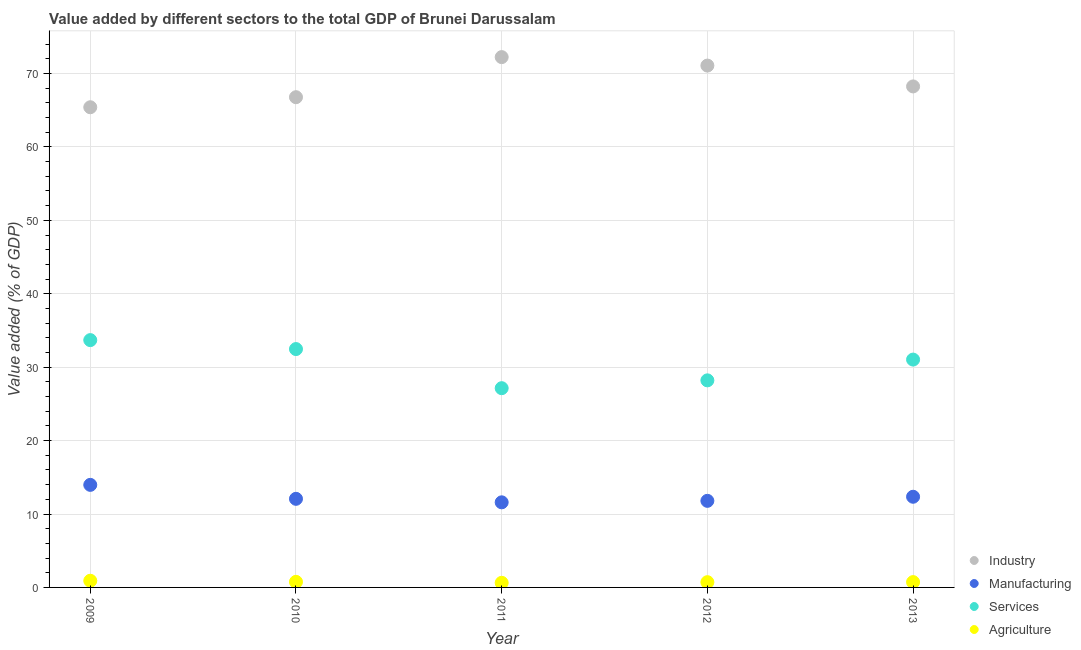What is the value added by manufacturing sector in 2010?
Make the answer very short. 12.07. Across all years, what is the maximum value added by industrial sector?
Give a very brief answer. 72.23. Across all years, what is the minimum value added by services sector?
Offer a terse response. 27.14. In which year was the value added by manufacturing sector minimum?
Ensure brevity in your answer.  2011. What is the total value added by manufacturing sector in the graph?
Give a very brief answer. 61.77. What is the difference between the value added by manufacturing sector in 2012 and that in 2013?
Your answer should be compact. -0.56. What is the difference between the value added by agricultural sector in 2011 and the value added by services sector in 2013?
Offer a very short reply. -30.41. What is the average value added by industrial sector per year?
Your response must be concise. 68.75. In the year 2011, what is the difference between the value added by manufacturing sector and value added by agricultural sector?
Make the answer very short. 10.96. In how many years, is the value added by services sector greater than 56 %?
Your answer should be compact. 0. What is the ratio of the value added by industrial sector in 2011 to that in 2013?
Your answer should be very brief. 1.06. What is the difference between the highest and the second highest value added by industrial sector?
Give a very brief answer. 1.15. What is the difference between the highest and the lowest value added by industrial sector?
Keep it short and to the point. 6.83. Is the sum of the value added by industrial sector in 2009 and 2012 greater than the maximum value added by services sector across all years?
Provide a short and direct response. Yes. Is it the case that in every year, the sum of the value added by manufacturing sector and value added by industrial sector is greater than the sum of value added by services sector and value added by agricultural sector?
Your response must be concise. Yes. Does the value added by industrial sector monotonically increase over the years?
Make the answer very short. No. Is the value added by manufacturing sector strictly less than the value added by agricultural sector over the years?
Your answer should be very brief. No. How many dotlines are there?
Your answer should be very brief. 4. How many years are there in the graph?
Offer a very short reply. 5. What is the difference between two consecutive major ticks on the Y-axis?
Provide a succinct answer. 10. Does the graph contain grids?
Your answer should be compact. Yes. Where does the legend appear in the graph?
Offer a very short reply. Bottom right. What is the title of the graph?
Offer a terse response. Value added by different sectors to the total GDP of Brunei Darussalam. Does "Secondary general" appear as one of the legend labels in the graph?
Give a very brief answer. No. What is the label or title of the Y-axis?
Offer a very short reply. Value added (% of GDP). What is the Value added (% of GDP) of Industry in 2009?
Your response must be concise. 65.41. What is the Value added (% of GDP) of Manufacturing in 2009?
Your answer should be compact. 13.97. What is the Value added (% of GDP) in Services in 2009?
Keep it short and to the point. 33.69. What is the Value added (% of GDP) in Agriculture in 2009?
Offer a very short reply. 0.91. What is the Value added (% of GDP) of Industry in 2010?
Keep it short and to the point. 66.77. What is the Value added (% of GDP) in Manufacturing in 2010?
Ensure brevity in your answer.  12.07. What is the Value added (% of GDP) of Services in 2010?
Ensure brevity in your answer.  32.47. What is the Value added (% of GDP) in Agriculture in 2010?
Make the answer very short. 0.76. What is the Value added (% of GDP) in Industry in 2011?
Your response must be concise. 72.23. What is the Value added (% of GDP) in Manufacturing in 2011?
Offer a very short reply. 11.59. What is the Value added (% of GDP) of Services in 2011?
Give a very brief answer. 27.14. What is the Value added (% of GDP) of Agriculture in 2011?
Make the answer very short. 0.63. What is the Value added (% of GDP) in Industry in 2012?
Your answer should be compact. 71.08. What is the Value added (% of GDP) in Manufacturing in 2012?
Ensure brevity in your answer.  11.79. What is the Value added (% of GDP) in Services in 2012?
Provide a succinct answer. 28.21. What is the Value added (% of GDP) in Agriculture in 2012?
Provide a short and direct response. 0.72. What is the Value added (% of GDP) in Industry in 2013?
Keep it short and to the point. 68.24. What is the Value added (% of GDP) of Manufacturing in 2013?
Your answer should be very brief. 12.35. What is the Value added (% of GDP) of Services in 2013?
Ensure brevity in your answer.  31.03. What is the Value added (% of GDP) in Agriculture in 2013?
Give a very brief answer. 0.73. Across all years, what is the maximum Value added (% of GDP) of Industry?
Keep it short and to the point. 72.23. Across all years, what is the maximum Value added (% of GDP) in Manufacturing?
Your response must be concise. 13.97. Across all years, what is the maximum Value added (% of GDP) in Services?
Make the answer very short. 33.69. Across all years, what is the maximum Value added (% of GDP) of Agriculture?
Provide a succinct answer. 0.91. Across all years, what is the minimum Value added (% of GDP) in Industry?
Your response must be concise. 65.41. Across all years, what is the minimum Value added (% of GDP) in Manufacturing?
Your answer should be compact. 11.59. Across all years, what is the minimum Value added (% of GDP) of Services?
Your answer should be compact. 27.14. Across all years, what is the minimum Value added (% of GDP) in Agriculture?
Ensure brevity in your answer.  0.63. What is the total Value added (% of GDP) of Industry in the graph?
Offer a very short reply. 343.73. What is the total Value added (% of GDP) of Manufacturing in the graph?
Keep it short and to the point. 61.77. What is the total Value added (% of GDP) in Services in the graph?
Keep it short and to the point. 152.53. What is the total Value added (% of GDP) in Agriculture in the graph?
Make the answer very short. 3.74. What is the difference between the Value added (% of GDP) of Industry in 2009 and that in 2010?
Give a very brief answer. -1.37. What is the difference between the Value added (% of GDP) of Manufacturing in 2009 and that in 2010?
Give a very brief answer. 1.9. What is the difference between the Value added (% of GDP) of Services in 2009 and that in 2010?
Make the answer very short. 1.22. What is the difference between the Value added (% of GDP) of Agriculture in 2009 and that in 2010?
Make the answer very short. 0.15. What is the difference between the Value added (% of GDP) of Industry in 2009 and that in 2011?
Keep it short and to the point. -6.83. What is the difference between the Value added (% of GDP) in Manufacturing in 2009 and that in 2011?
Provide a succinct answer. 2.38. What is the difference between the Value added (% of GDP) in Services in 2009 and that in 2011?
Make the answer very short. 6.55. What is the difference between the Value added (% of GDP) of Agriculture in 2009 and that in 2011?
Your answer should be very brief. 0.28. What is the difference between the Value added (% of GDP) in Industry in 2009 and that in 2012?
Offer a terse response. -5.67. What is the difference between the Value added (% of GDP) in Manufacturing in 2009 and that in 2012?
Your response must be concise. 2.18. What is the difference between the Value added (% of GDP) in Services in 2009 and that in 2012?
Your response must be concise. 5.48. What is the difference between the Value added (% of GDP) of Agriculture in 2009 and that in 2012?
Provide a short and direct response. 0.19. What is the difference between the Value added (% of GDP) of Industry in 2009 and that in 2013?
Provide a succinct answer. -2.84. What is the difference between the Value added (% of GDP) in Manufacturing in 2009 and that in 2013?
Ensure brevity in your answer.  1.62. What is the difference between the Value added (% of GDP) of Services in 2009 and that in 2013?
Your answer should be very brief. 2.65. What is the difference between the Value added (% of GDP) of Agriculture in 2009 and that in 2013?
Provide a short and direct response. 0.18. What is the difference between the Value added (% of GDP) of Industry in 2010 and that in 2011?
Provide a succinct answer. -5.46. What is the difference between the Value added (% of GDP) in Manufacturing in 2010 and that in 2011?
Provide a succinct answer. 0.48. What is the difference between the Value added (% of GDP) in Services in 2010 and that in 2011?
Provide a succinct answer. 5.33. What is the difference between the Value added (% of GDP) in Agriculture in 2010 and that in 2011?
Provide a short and direct response. 0.13. What is the difference between the Value added (% of GDP) of Industry in 2010 and that in 2012?
Ensure brevity in your answer.  -4.31. What is the difference between the Value added (% of GDP) in Manufacturing in 2010 and that in 2012?
Your response must be concise. 0.27. What is the difference between the Value added (% of GDP) in Services in 2010 and that in 2012?
Your answer should be very brief. 4.26. What is the difference between the Value added (% of GDP) of Agriculture in 2010 and that in 2012?
Offer a terse response. 0.04. What is the difference between the Value added (% of GDP) in Industry in 2010 and that in 2013?
Your answer should be compact. -1.47. What is the difference between the Value added (% of GDP) in Manufacturing in 2010 and that in 2013?
Provide a succinct answer. -0.28. What is the difference between the Value added (% of GDP) of Services in 2010 and that in 2013?
Offer a very short reply. 1.43. What is the difference between the Value added (% of GDP) in Agriculture in 2010 and that in 2013?
Your answer should be compact. 0.03. What is the difference between the Value added (% of GDP) in Industry in 2011 and that in 2012?
Offer a terse response. 1.15. What is the difference between the Value added (% of GDP) of Manufacturing in 2011 and that in 2012?
Make the answer very short. -0.2. What is the difference between the Value added (% of GDP) in Services in 2011 and that in 2012?
Ensure brevity in your answer.  -1.07. What is the difference between the Value added (% of GDP) of Agriculture in 2011 and that in 2012?
Keep it short and to the point. -0.09. What is the difference between the Value added (% of GDP) in Industry in 2011 and that in 2013?
Your response must be concise. 3.99. What is the difference between the Value added (% of GDP) of Manufacturing in 2011 and that in 2013?
Give a very brief answer. -0.76. What is the difference between the Value added (% of GDP) in Services in 2011 and that in 2013?
Your answer should be compact. -3.9. What is the difference between the Value added (% of GDP) of Agriculture in 2011 and that in 2013?
Your answer should be very brief. -0.1. What is the difference between the Value added (% of GDP) in Industry in 2012 and that in 2013?
Offer a very short reply. 2.84. What is the difference between the Value added (% of GDP) of Manufacturing in 2012 and that in 2013?
Your answer should be compact. -0.56. What is the difference between the Value added (% of GDP) of Services in 2012 and that in 2013?
Offer a terse response. -2.83. What is the difference between the Value added (% of GDP) of Agriculture in 2012 and that in 2013?
Offer a very short reply. -0.01. What is the difference between the Value added (% of GDP) of Industry in 2009 and the Value added (% of GDP) of Manufacturing in 2010?
Your answer should be compact. 53.34. What is the difference between the Value added (% of GDP) in Industry in 2009 and the Value added (% of GDP) in Services in 2010?
Your answer should be compact. 32.94. What is the difference between the Value added (% of GDP) in Industry in 2009 and the Value added (% of GDP) in Agriculture in 2010?
Keep it short and to the point. 64.65. What is the difference between the Value added (% of GDP) in Manufacturing in 2009 and the Value added (% of GDP) in Services in 2010?
Keep it short and to the point. -18.5. What is the difference between the Value added (% of GDP) in Manufacturing in 2009 and the Value added (% of GDP) in Agriculture in 2010?
Offer a terse response. 13.21. What is the difference between the Value added (% of GDP) of Services in 2009 and the Value added (% of GDP) of Agriculture in 2010?
Give a very brief answer. 32.93. What is the difference between the Value added (% of GDP) of Industry in 2009 and the Value added (% of GDP) of Manufacturing in 2011?
Give a very brief answer. 53.81. What is the difference between the Value added (% of GDP) of Industry in 2009 and the Value added (% of GDP) of Services in 2011?
Keep it short and to the point. 38.27. What is the difference between the Value added (% of GDP) of Industry in 2009 and the Value added (% of GDP) of Agriculture in 2011?
Your answer should be compact. 64.78. What is the difference between the Value added (% of GDP) of Manufacturing in 2009 and the Value added (% of GDP) of Services in 2011?
Make the answer very short. -13.17. What is the difference between the Value added (% of GDP) of Manufacturing in 2009 and the Value added (% of GDP) of Agriculture in 2011?
Provide a short and direct response. 13.34. What is the difference between the Value added (% of GDP) of Services in 2009 and the Value added (% of GDP) of Agriculture in 2011?
Ensure brevity in your answer.  33.06. What is the difference between the Value added (% of GDP) in Industry in 2009 and the Value added (% of GDP) in Manufacturing in 2012?
Make the answer very short. 53.61. What is the difference between the Value added (% of GDP) of Industry in 2009 and the Value added (% of GDP) of Services in 2012?
Provide a succinct answer. 37.2. What is the difference between the Value added (% of GDP) in Industry in 2009 and the Value added (% of GDP) in Agriculture in 2012?
Your answer should be compact. 64.69. What is the difference between the Value added (% of GDP) in Manufacturing in 2009 and the Value added (% of GDP) in Services in 2012?
Ensure brevity in your answer.  -14.24. What is the difference between the Value added (% of GDP) of Manufacturing in 2009 and the Value added (% of GDP) of Agriculture in 2012?
Your response must be concise. 13.25. What is the difference between the Value added (% of GDP) of Services in 2009 and the Value added (% of GDP) of Agriculture in 2012?
Your answer should be compact. 32.97. What is the difference between the Value added (% of GDP) of Industry in 2009 and the Value added (% of GDP) of Manufacturing in 2013?
Ensure brevity in your answer.  53.06. What is the difference between the Value added (% of GDP) of Industry in 2009 and the Value added (% of GDP) of Services in 2013?
Your response must be concise. 34.37. What is the difference between the Value added (% of GDP) in Industry in 2009 and the Value added (% of GDP) in Agriculture in 2013?
Keep it short and to the point. 64.68. What is the difference between the Value added (% of GDP) of Manufacturing in 2009 and the Value added (% of GDP) of Services in 2013?
Ensure brevity in your answer.  -17.06. What is the difference between the Value added (% of GDP) in Manufacturing in 2009 and the Value added (% of GDP) in Agriculture in 2013?
Provide a succinct answer. 13.24. What is the difference between the Value added (% of GDP) of Services in 2009 and the Value added (% of GDP) of Agriculture in 2013?
Your answer should be compact. 32.96. What is the difference between the Value added (% of GDP) of Industry in 2010 and the Value added (% of GDP) of Manufacturing in 2011?
Ensure brevity in your answer.  55.18. What is the difference between the Value added (% of GDP) in Industry in 2010 and the Value added (% of GDP) in Services in 2011?
Provide a short and direct response. 39.63. What is the difference between the Value added (% of GDP) of Industry in 2010 and the Value added (% of GDP) of Agriculture in 2011?
Provide a short and direct response. 66.14. What is the difference between the Value added (% of GDP) in Manufacturing in 2010 and the Value added (% of GDP) in Services in 2011?
Offer a very short reply. -15.07. What is the difference between the Value added (% of GDP) in Manufacturing in 2010 and the Value added (% of GDP) in Agriculture in 2011?
Your answer should be compact. 11.44. What is the difference between the Value added (% of GDP) of Services in 2010 and the Value added (% of GDP) of Agriculture in 2011?
Give a very brief answer. 31.84. What is the difference between the Value added (% of GDP) of Industry in 2010 and the Value added (% of GDP) of Manufacturing in 2012?
Your answer should be very brief. 54.98. What is the difference between the Value added (% of GDP) of Industry in 2010 and the Value added (% of GDP) of Services in 2012?
Make the answer very short. 38.57. What is the difference between the Value added (% of GDP) of Industry in 2010 and the Value added (% of GDP) of Agriculture in 2012?
Provide a short and direct response. 66.06. What is the difference between the Value added (% of GDP) of Manufacturing in 2010 and the Value added (% of GDP) of Services in 2012?
Your response must be concise. -16.14. What is the difference between the Value added (% of GDP) of Manufacturing in 2010 and the Value added (% of GDP) of Agriculture in 2012?
Ensure brevity in your answer.  11.35. What is the difference between the Value added (% of GDP) in Services in 2010 and the Value added (% of GDP) in Agriculture in 2012?
Keep it short and to the point. 31.75. What is the difference between the Value added (% of GDP) of Industry in 2010 and the Value added (% of GDP) of Manufacturing in 2013?
Your response must be concise. 54.42. What is the difference between the Value added (% of GDP) in Industry in 2010 and the Value added (% of GDP) in Services in 2013?
Offer a very short reply. 35.74. What is the difference between the Value added (% of GDP) of Industry in 2010 and the Value added (% of GDP) of Agriculture in 2013?
Offer a terse response. 66.05. What is the difference between the Value added (% of GDP) of Manufacturing in 2010 and the Value added (% of GDP) of Services in 2013?
Make the answer very short. -18.97. What is the difference between the Value added (% of GDP) of Manufacturing in 2010 and the Value added (% of GDP) of Agriculture in 2013?
Your answer should be very brief. 11.34. What is the difference between the Value added (% of GDP) in Services in 2010 and the Value added (% of GDP) in Agriculture in 2013?
Ensure brevity in your answer.  31.74. What is the difference between the Value added (% of GDP) of Industry in 2011 and the Value added (% of GDP) of Manufacturing in 2012?
Provide a succinct answer. 60.44. What is the difference between the Value added (% of GDP) of Industry in 2011 and the Value added (% of GDP) of Services in 2012?
Offer a very short reply. 44.03. What is the difference between the Value added (% of GDP) of Industry in 2011 and the Value added (% of GDP) of Agriculture in 2012?
Offer a terse response. 71.52. What is the difference between the Value added (% of GDP) of Manufacturing in 2011 and the Value added (% of GDP) of Services in 2012?
Offer a very short reply. -16.61. What is the difference between the Value added (% of GDP) of Manufacturing in 2011 and the Value added (% of GDP) of Agriculture in 2012?
Offer a terse response. 10.88. What is the difference between the Value added (% of GDP) in Services in 2011 and the Value added (% of GDP) in Agriculture in 2012?
Offer a terse response. 26.42. What is the difference between the Value added (% of GDP) in Industry in 2011 and the Value added (% of GDP) in Manufacturing in 2013?
Provide a short and direct response. 59.88. What is the difference between the Value added (% of GDP) in Industry in 2011 and the Value added (% of GDP) in Services in 2013?
Ensure brevity in your answer.  41.2. What is the difference between the Value added (% of GDP) of Industry in 2011 and the Value added (% of GDP) of Agriculture in 2013?
Ensure brevity in your answer.  71.51. What is the difference between the Value added (% of GDP) in Manufacturing in 2011 and the Value added (% of GDP) in Services in 2013?
Ensure brevity in your answer.  -19.44. What is the difference between the Value added (% of GDP) of Manufacturing in 2011 and the Value added (% of GDP) of Agriculture in 2013?
Ensure brevity in your answer.  10.87. What is the difference between the Value added (% of GDP) in Services in 2011 and the Value added (% of GDP) in Agriculture in 2013?
Provide a succinct answer. 26.41. What is the difference between the Value added (% of GDP) in Industry in 2012 and the Value added (% of GDP) in Manufacturing in 2013?
Make the answer very short. 58.73. What is the difference between the Value added (% of GDP) of Industry in 2012 and the Value added (% of GDP) of Services in 2013?
Give a very brief answer. 40.05. What is the difference between the Value added (% of GDP) in Industry in 2012 and the Value added (% of GDP) in Agriculture in 2013?
Keep it short and to the point. 70.35. What is the difference between the Value added (% of GDP) in Manufacturing in 2012 and the Value added (% of GDP) in Services in 2013?
Provide a short and direct response. -19.24. What is the difference between the Value added (% of GDP) in Manufacturing in 2012 and the Value added (% of GDP) in Agriculture in 2013?
Your answer should be very brief. 11.07. What is the difference between the Value added (% of GDP) of Services in 2012 and the Value added (% of GDP) of Agriculture in 2013?
Keep it short and to the point. 27.48. What is the average Value added (% of GDP) of Industry per year?
Make the answer very short. 68.75. What is the average Value added (% of GDP) in Manufacturing per year?
Your response must be concise. 12.35. What is the average Value added (% of GDP) of Services per year?
Give a very brief answer. 30.51. What is the average Value added (% of GDP) in Agriculture per year?
Ensure brevity in your answer.  0.75. In the year 2009, what is the difference between the Value added (% of GDP) of Industry and Value added (% of GDP) of Manufacturing?
Give a very brief answer. 51.44. In the year 2009, what is the difference between the Value added (% of GDP) of Industry and Value added (% of GDP) of Services?
Keep it short and to the point. 31.72. In the year 2009, what is the difference between the Value added (% of GDP) in Industry and Value added (% of GDP) in Agriculture?
Keep it short and to the point. 64.5. In the year 2009, what is the difference between the Value added (% of GDP) in Manufacturing and Value added (% of GDP) in Services?
Offer a very short reply. -19.72. In the year 2009, what is the difference between the Value added (% of GDP) in Manufacturing and Value added (% of GDP) in Agriculture?
Give a very brief answer. 13.06. In the year 2009, what is the difference between the Value added (% of GDP) of Services and Value added (% of GDP) of Agriculture?
Ensure brevity in your answer.  32.78. In the year 2010, what is the difference between the Value added (% of GDP) in Industry and Value added (% of GDP) in Manufacturing?
Ensure brevity in your answer.  54.71. In the year 2010, what is the difference between the Value added (% of GDP) in Industry and Value added (% of GDP) in Services?
Offer a very short reply. 34.31. In the year 2010, what is the difference between the Value added (% of GDP) in Industry and Value added (% of GDP) in Agriculture?
Offer a terse response. 66.01. In the year 2010, what is the difference between the Value added (% of GDP) of Manufacturing and Value added (% of GDP) of Services?
Keep it short and to the point. -20.4. In the year 2010, what is the difference between the Value added (% of GDP) in Manufacturing and Value added (% of GDP) in Agriculture?
Make the answer very short. 11.31. In the year 2010, what is the difference between the Value added (% of GDP) of Services and Value added (% of GDP) of Agriculture?
Your answer should be very brief. 31.71. In the year 2011, what is the difference between the Value added (% of GDP) of Industry and Value added (% of GDP) of Manufacturing?
Your response must be concise. 60.64. In the year 2011, what is the difference between the Value added (% of GDP) in Industry and Value added (% of GDP) in Services?
Your answer should be compact. 45.09. In the year 2011, what is the difference between the Value added (% of GDP) in Industry and Value added (% of GDP) in Agriculture?
Provide a succinct answer. 71.61. In the year 2011, what is the difference between the Value added (% of GDP) of Manufacturing and Value added (% of GDP) of Services?
Keep it short and to the point. -15.55. In the year 2011, what is the difference between the Value added (% of GDP) in Manufacturing and Value added (% of GDP) in Agriculture?
Your answer should be very brief. 10.96. In the year 2011, what is the difference between the Value added (% of GDP) of Services and Value added (% of GDP) of Agriculture?
Provide a succinct answer. 26.51. In the year 2012, what is the difference between the Value added (% of GDP) of Industry and Value added (% of GDP) of Manufacturing?
Provide a short and direct response. 59.29. In the year 2012, what is the difference between the Value added (% of GDP) in Industry and Value added (% of GDP) in Services?
Offer a terse response. 42.87. In the year 2012, what is the difference between the Value added (% of GDP) in Industry and Value added (% of GDP) in Agriculture?
Your answer should be very brief. 70.36. In the year 2012, what is the difference between the Value added (% of GDP) in Manufacturing and Value added (% of GDP) in Services?
Keep it short and to the point. -16.41. In the year 2012, what is the difference between the Value added (% of GDP) of Manufacturing and Value added (% of GDP) of Agriculture?
Make the answer very short. 11.08. In the year 2012, what is the difference between the Value added (% of GDP) of Services and Value added (% of GDP) of Agriculture?
Provide a short and direct response. 27.49. In the year 2013, what is the difference between the Value added (% of GDP) of Industry and Value added (% of GDP) of Manufacturing?
Ensure brevity in your answer.  55.89. In the year 2013, what is the difference between the Value added (% of GDP) in Industry and Value added (% of GDP) in Services?
Provide a succinct answer. 37.21. In the year 2013, what is the difference between the Value added (% of GDP) in Industry and Value added (% of GDP) in Agriculture?
Provide a succinct answer. 67.51. In the year 2013, what is the difference between the Value added (% of GDP) in Manufacturing and Value added (% of GDP) in Services?
Ensure brevity in your answer.  -18.68. In the year 2013, what is the difference between the Value added (% of GDP) of Manufacturing and Value added (% of GDP) of Agriculture?
Ensure brevity in your answer.  11.62. In the year 2013, what is the difference between the Value added (% of GDP) of Services and Value added (% of GDP) of Agriculture?
Your response must be concise. 30.31. What is the ratio of the Value added (% of GDP) of Industry in 2009 to that in 2010?
Give a very brief answer. 0.98. What is the ratio of the Value added (% of GDP) in Manufacturing in 2009 to that in 2010?
Make the answer very short. 1.16. What is the ratio of the Value added (% of GDP) in Services in 2009 to that in 2010?
Ensure brevity in your answer.  1.04. What is the ratio of the Value added (% of GDP) of Agriculture in 2009 to that in 2010?
Your response must be concise. 1.2. What is the ratio of the Value added (% of GDP) of Industry in 2009 to that in 2011?
Your answer should be compact. 0.91. What is the ratio of the Value added (% of GDP) of Manufacturing in 2009 to that in 2011?
Keep it short and to the point. 1.21. What is the ratio of the Value added (% of GDP) in Services in 2009 to that in 2011?
Make the answer very short. 1.24. What is the ratio of the Value added (% of GDP) of Agriculture in 2009 to that in 2011?
Ensure brevity in your answer.  1.45. What is the ratio of the Value added (% of GDP) in Industry in 2009 to that in 2012?
Offer a terse response. 0.92. What is the ratio of the Value added (% of GDP) in Manufacturing in 2009 to that in 2012?
Ensure brevity in your answer.  1.18. What is the ratio of the Value added (% of GDP) in Services in 2009 to that in 2012?
Your answer should be very brief. 1.19. What is the ratio of the Value added (% of GDP) in Agriculture in 2009 to that in 2012?
Make the answer very short. 1.27. What is the ratio of the Value added (% of GDP) in Industry in 2009 to that in 2013?
Your response must be concise. 0.96. What is the ratio of the Value added (% of GDP) in Manufacturing in 2009 to that in 2013?
Provide a succinct answer. 1.13. What is the ratio of the Value added (% of GDP) in Services in 2009 to that in 2013?
Make the answer very short. 1.09. What is the ratio of the Value added (% of GDP) in Agriculture in 2009 to that in 2013?
Provide a short and direct response. 1.25. What is the ratio of the Value added (% of GDP) of Industry in 2010 to that in 2011?
Offer a very short reply. 0.92. What is the ratio of the Value added (% of GDP) of Manufacturing in 2010 to that in 2011?
Offer a very short reply. 1.04. What is the ratio of the Value added (% of GDP) in Services in 2010 to that in 2011?
Give a very brief answer. 1.2. What is the ratio of the Value added (% of GDP) in Agriculture in 2010 to that in 2011?
Your answer should be compact. 1.21. What is the ratio of the Value added (% of GDP) in Industry in 2010 to that in 2012?
Make the answer very short. 0.94. What is the ratio of the Value added (% of GDP) in Manufacturing in 2010 to that in 2012?
Your response must be concise. 1.02. What is the ratio of the Value added (% of GDP) of Services in 2010 to that in 2012?
Keep it short and to the point. 1.15. What is the ratio of the Value added (% of GDP) of Industry in 2010 to that in 2013?
Keep it short and to the point. 0.98. What is the ratio of the Value added (% of GDP) in Manufacturing in 2010 to that in 2013?
Keep it short and to the point. 0.98. What is the ratio of the Value added (% of GDP) in Services in 2010 to that in 2013?
Offer a terse response. 1.05. What is the ratio of the Value added (% of GDP) in Agriculture in 2010 to that in 2013?
Provide a succinct answer. 1.05. What is the ratio of the Value added (% of GDP) of Industry in 2011 to that in 2012?
Offer a very short reply. 1.02. What is the ratio of the Value added (% of GDP) in Manufacturing in 2011 to that in 2012?
Your answer should be compact. 0.98. What is the ratio of the Value added (% of GDP) of Services in 2011 to that in 2012?
Keep it short and to the point. 0.96. What is the ratio of the Value added (% of GDP) of Agriculture in 2011 to that in 2012?
Your response must be concise. 0.88. What is the ratio of the Value added (% of GDP) of Industry in 2011 to that in 2013?
Offer a terse response. 1.06. What is the ratio of the Value added (% of GDP) of Manufacturing in 2011 to that in 2013?
Provide a succinct answer. 0.94. What is the ratio of the Value added (% of GDP) in Services in 2011 to that in 2013?
Your response must be concise. 0.87. What is the ratio of the Value added (% of GDP) of Agriculture in 2011 to that in 2013?
Ensure brevity in your answer.  0.87. What is the ratio of the Value added (% of GDP) in Industry in 2012 to that in 2013?
Provide a succinct answer. 1.04. What is the ratio of the Value added (% of GDP) of Manufacturing in 2012 to that in 2013?
Your answer should be very brief. 0.95. What is the ratio of the Value added (% of GDP) in Services in 2012 to that in 2013?
Make the answer very short. 0.91. What is the difference between the highest and the second highest Value added (% of GDP) in Industry?
Your response must be concise. 1.15. What is the difference between the highest and the second highest Value added (% of GDP) of Manufacturing?
Ensure brevity in your answer.  1.62. What is the difference between the highest and the second highest Value added (% of GDP) of Services?
Keep it short and to the point. 1.22. What is the difference between the highest and the second highest Value added (% of GDP) of Agriculture?
Provide a succinct answer. 0.15. What is the difference between the highest and the lowest Value added (% of GDP) in Industry?
Your answer should be very brief. 6.83. What is the difference between the highest and the lowest Value added (% of GDP) in Manufacturing?
Give a very brief answer. 2.38. What is the difference between the highest and the lowest Value added (% of GDP) of Services?
Keep it short and to the point. 6.55. What is the difference between the highest and the lowest Value added (% of GDP) of Agriculture?
Offer a very short reply. 0.28. 